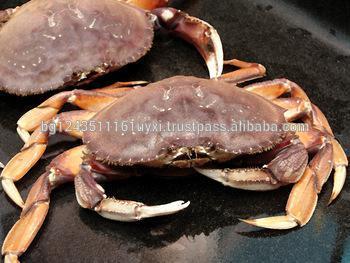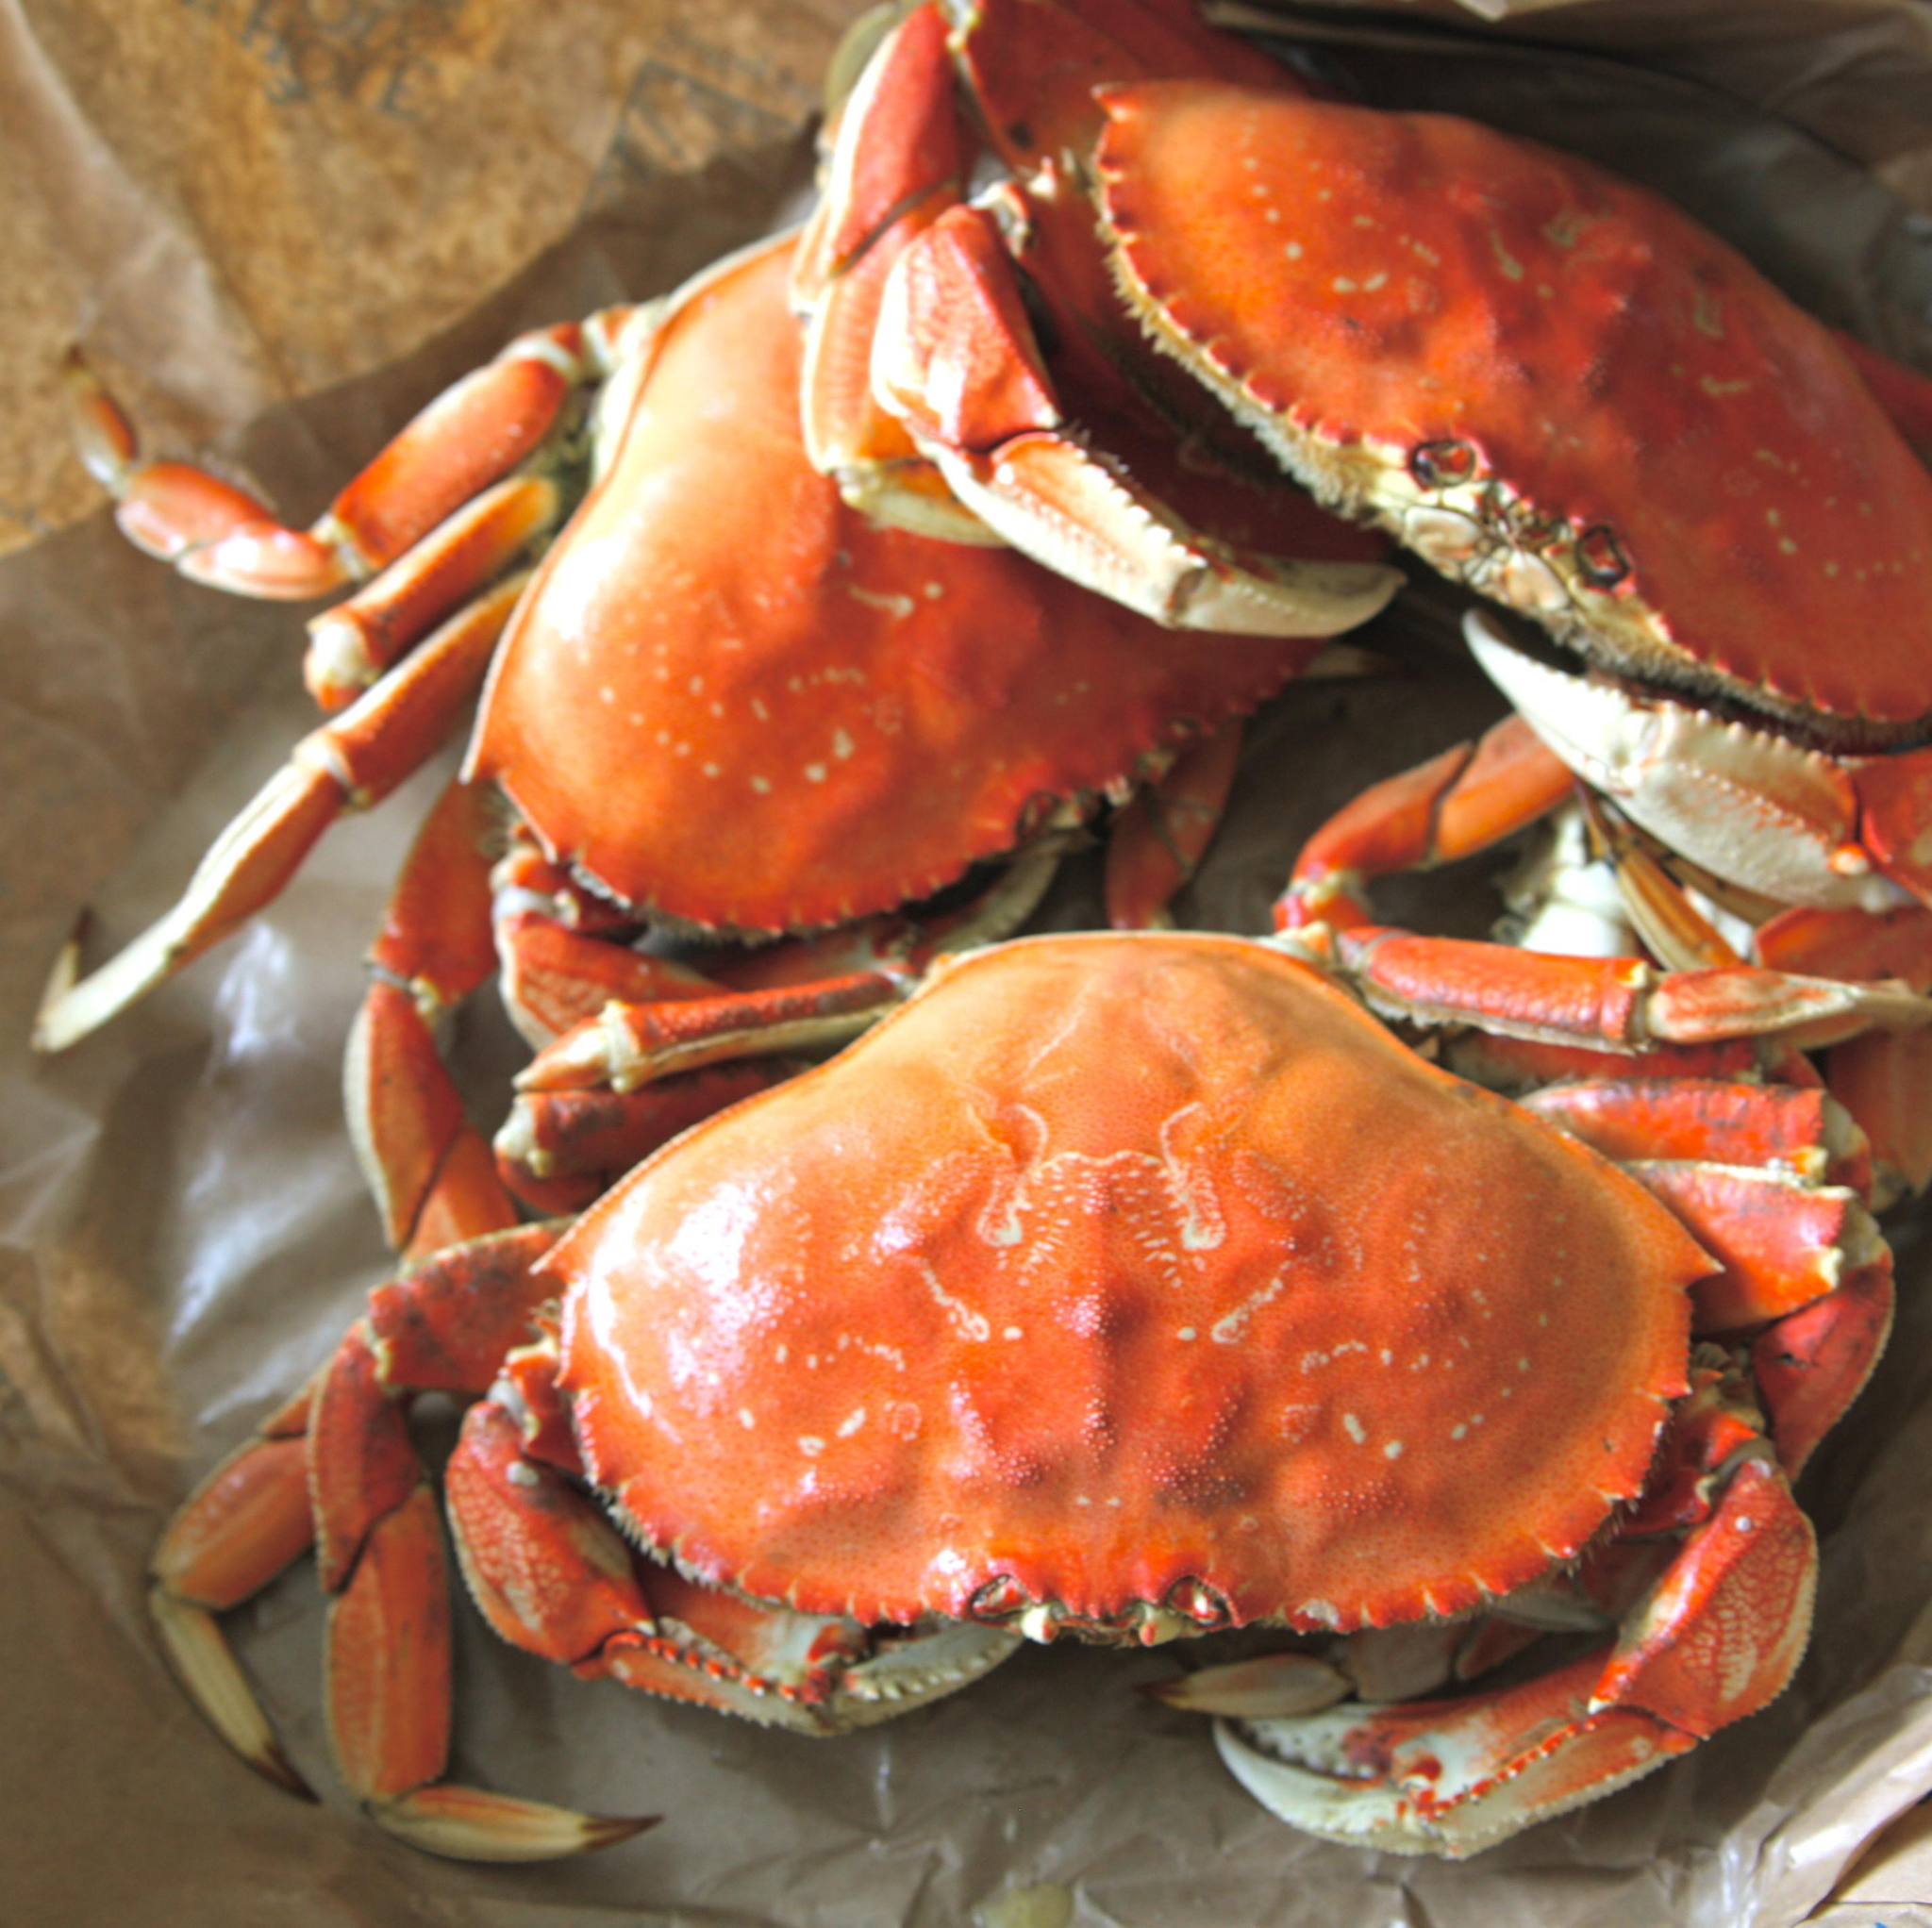The first image is the image on the left, the second image is the image on the right. Analyze the images presented: Is the assertion "At least one beverage in a clear glass is on the right of a pile of seafood with claws in one image." valid? Answer yes or no. No. The first image is the image on the left, the second image is the image on the right. For the images displayed, is the sentence "The crabs in one of the images are being served with drinks." factually correct? Answer yes or no. No. 